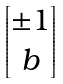Convert formula to latex. <formula><loc_0><loc_0><loc_500><loc_500>\begin{bmatrix} \pm 1 \\ b \end{bmatrix}</formula> 